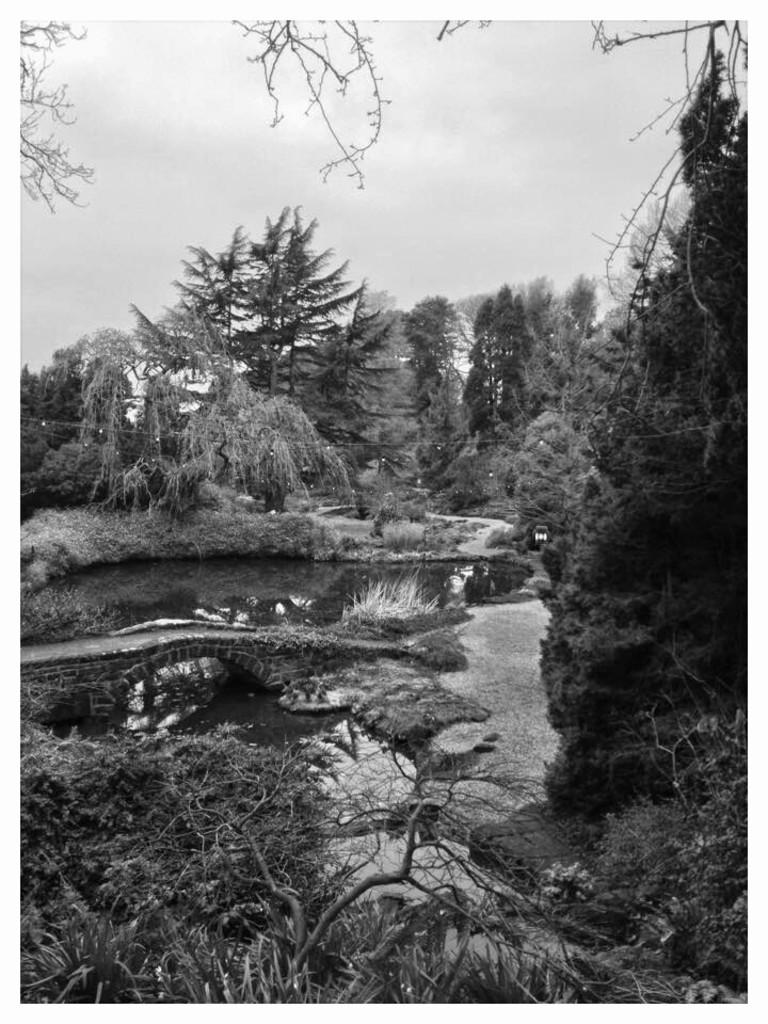What is the color scheme of the image? The image is black and white. What type of vegetation can be seen in the image? There are trees in the image. What structure is present in the image? There is a stone bridge in the image. What natural element is visible in the image? There is water visible in the image. What is visible in the background of the image? The sky is visible in the background of the image. Reasoning: Let' Let's think step by step in order to produce the conversation. We start by identifying the color scheme of the image, which is black and white. Then, we describe the main subjects and objects in the image, including the trees, stone bridge, water, and sky. Each question is designed to elicit a specific detail about the image that is known from the provided facts. Absurd Question/Answer: What type of attraction can be seen in the image? There is no attraction present in the image; it features a black and white scene with trees, a stone bridge, water, and the sky. Can you tell me who is controlling the water in the image? There is no person or entity controlling the water in the image; it is a natural element flowing under the stone bridge. 